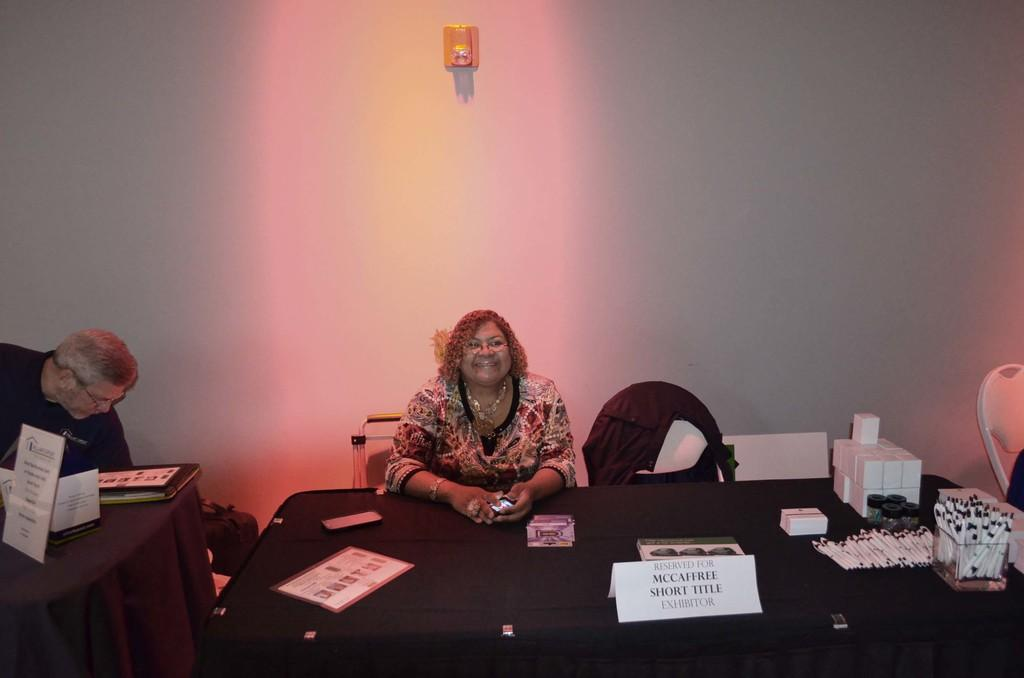What is the woman doing in the image? The woman is sitting on a chair in the image. Where is the chair located in relation to the table? The chair is around a table. What items can be seen on the table? There are pens, a name board, and a mobile phone on the table. What is visible in the background of the image? There is a wall in the background of the image. What type of guide is the woman holding in the image? There is no guide present in the image; the woman is sitting on a chair and there are items on the table, but no guide. 